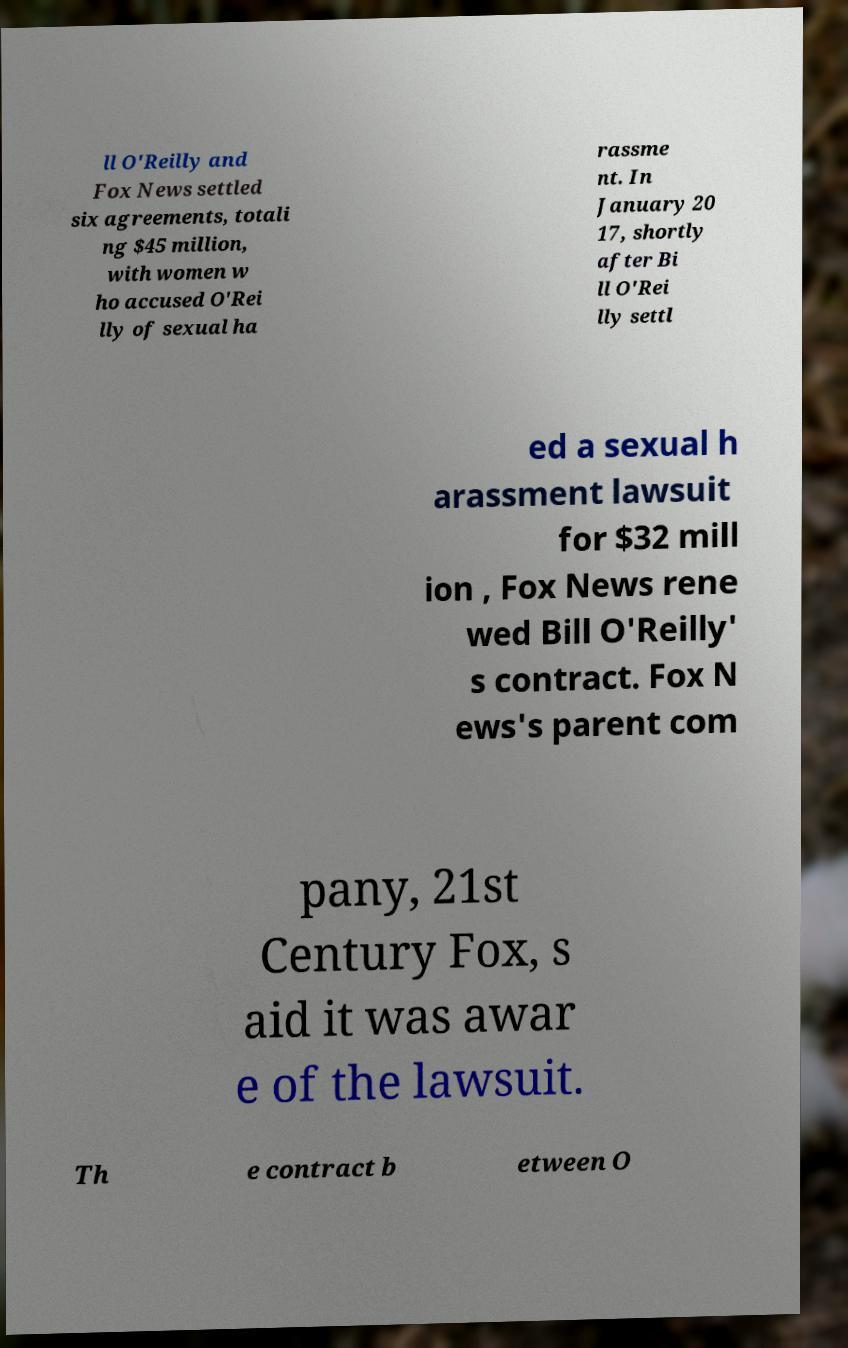For documentation purposes, I need the text within this image transcribed. Could you provide that? ll O'Reilly and Fox News settled six agreements, totali ng $45 million, with women w ho accused O'Rei lly of sexual ha rassme nt. In January 20 17, shortly after Bi ll O'Rei lly settl ed a sexual h arassment lawsuit for $32 mill ion , Fox News rene wed Bill O'Reilly' s contract. Fox N ews's parent com pany, 21st Century Fox, s aid it was awar e of the lawsuit. Th e contract b etween O 